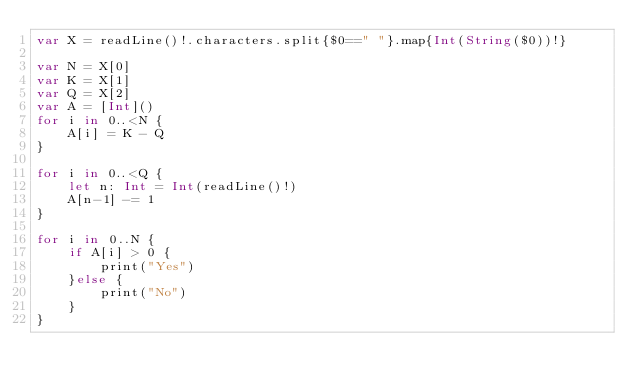Convert code to text. <code><loc_0><loc_0><loc_500><loc_500><_Swift_>var X = readLine()!.characters.split{$0==" "}.map{Int(String($0))!}

var N = X[0]
var K = X[1]
var Q = X[2]
var A = [Int]()
for i in 0..<N {
    A[i] = K - Q
}

for i in 0..<Q {
    let n: Int = Int(readLine()!)
    A[n-1] -= 1
}

for i in 0..N {
    if A[i] > 0 {
        print("Yes")
    }else {
        print("No")
    }
}

</code> 